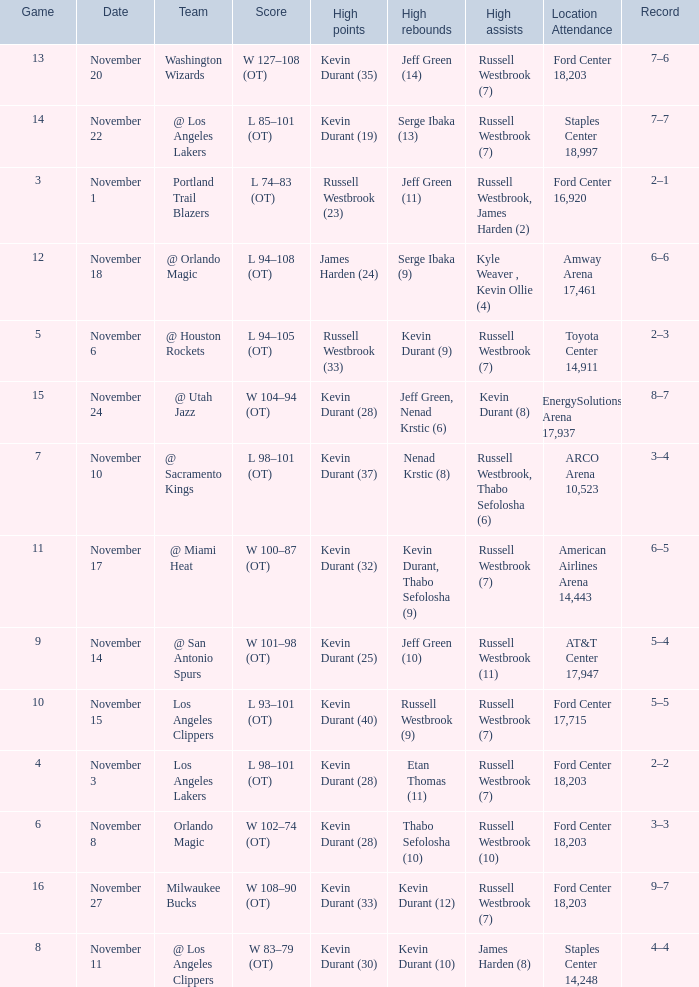What was the record in the game in which Jeff Green (14) did the most high rebounds? 7–6. 